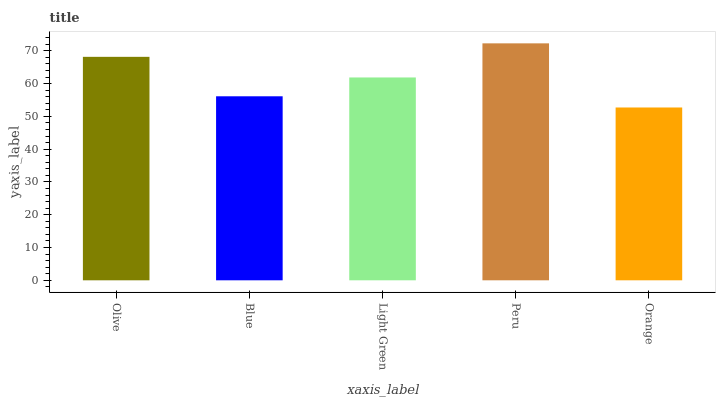Is Orange the minimum?
Answer yes or no. Yes. Is Peru the maximum?
Answer yes or no. Yes. Is Blue the minimum?
Answer yes or no. No. Is Blue the maximum?
Answer yes or no. No. Is Olive greater than Blue?
Answer yes or no. Yes. Is Blue less than Olive?
Answer yes or no. Yes. Is Blue greater than Olive?
Answer yes or no. No. Is Olive less than Blue?
Answer yes or no. No. Is Light Green the high median?
Answer yes or no. Yes. Is Light Green the low median?
Answer yes or no. Yes. Is Orange the high median?
Answer yes or no. No. Is Orange the low median?
Answer yes or no. No. 